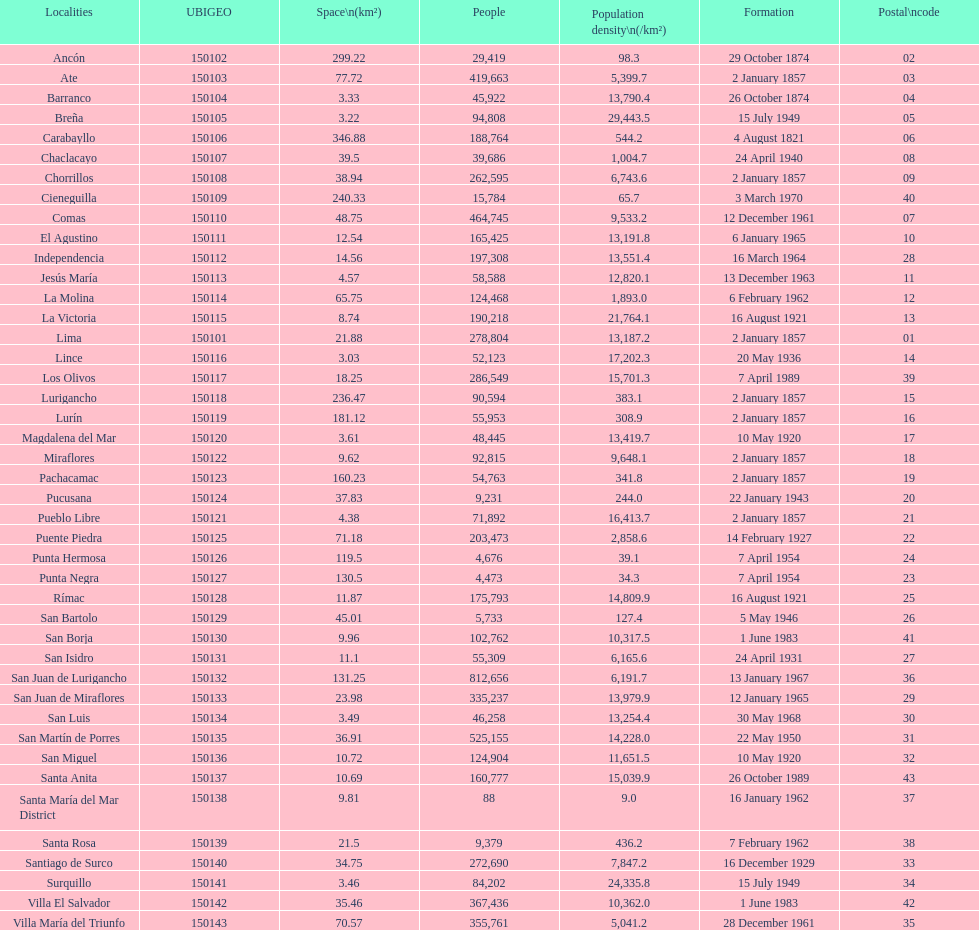In which district is the population the smallest? Santa María del Mar District. 